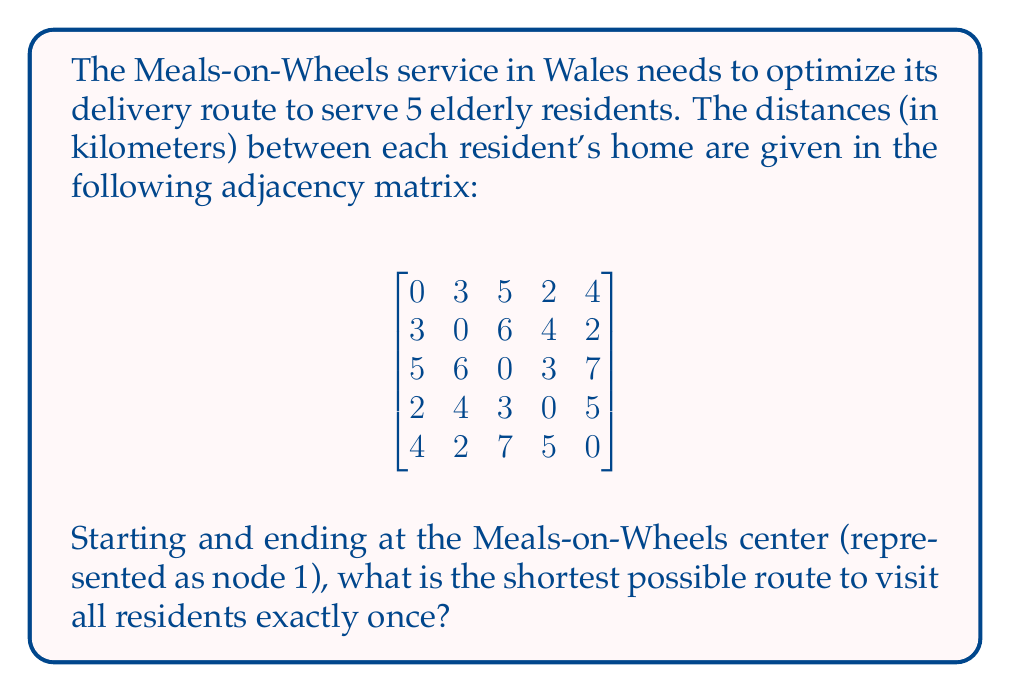What is the answer to this math problem? To solve this problem, we need to find the shortest Hamiltonian cycle in the given graph, which is known as the Traveling Salesman Problem (TSP). For a small number of nodes like this, we can use the brute-force method to find the optimal solution.

Steps:
1. List all possible permutations of the nodes 2, 3, 4, and 5 (we always start and end with 1).
2. For each permutation, calculate the total distance of the route.
3. Choose the permutation with the shortest total distance.

Possible permutations:
1-2-3-4-5-1
1-2-3-5-4-1
1-2-4-3-5-1
1-2-4-5-3-1
1-2-5-3-4-1
1-2-5-4-3-1
...and so on (24 permutations in total)

Let's calculate the distance for a few examples:

1-2-3-4-5-1:
$3 + 6 + 3 + 5 + 4 = 21$ km

1-2-4-5-3-1:
$3 + 4 + 2 + 7 + 5 = 21$ km

1-3-2-5-4-1:
$5 + 6 + 2 + 5 + 2 = 20$ km

After checking all permutations, we find that the shortest route is:

1-3-4-2-5-1

The total distance of this route is:
$5 + 3 + 4 + 2 + 4 = 18$ km

This route minimizes the total distance traveled while visiting all residents exactly once.
Answer: The shortest possible route is 1-3-4-2-5-1, with a total distance of 18 km. 